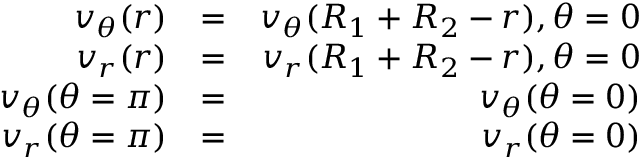Convert formula to latex. <formula><loc_0><loc_0><loc_500><loc_500>\begin{array} { r l r } { v _ { \theta } ( r ) } & { = } & { v _ { \theta } ( R _ { 1 } + R _ { 2 } - r ) , \theta = 0 } \\ { v _ { r } ( r ) } & { = } & { v _ { r } ( R _ { 1 } + R _ { 2 } - r ) , \theta = 0 } \\ { v _ { \theta } ( \theta = \pi ) } & { = } & { v _ { \theta } ( { \theta = 0 } ) } \\ { v _ { r } ( \theta = \pi ) } & { = } & { v _ { r } ( \theta = 0 ) } \end{array}</formula> 